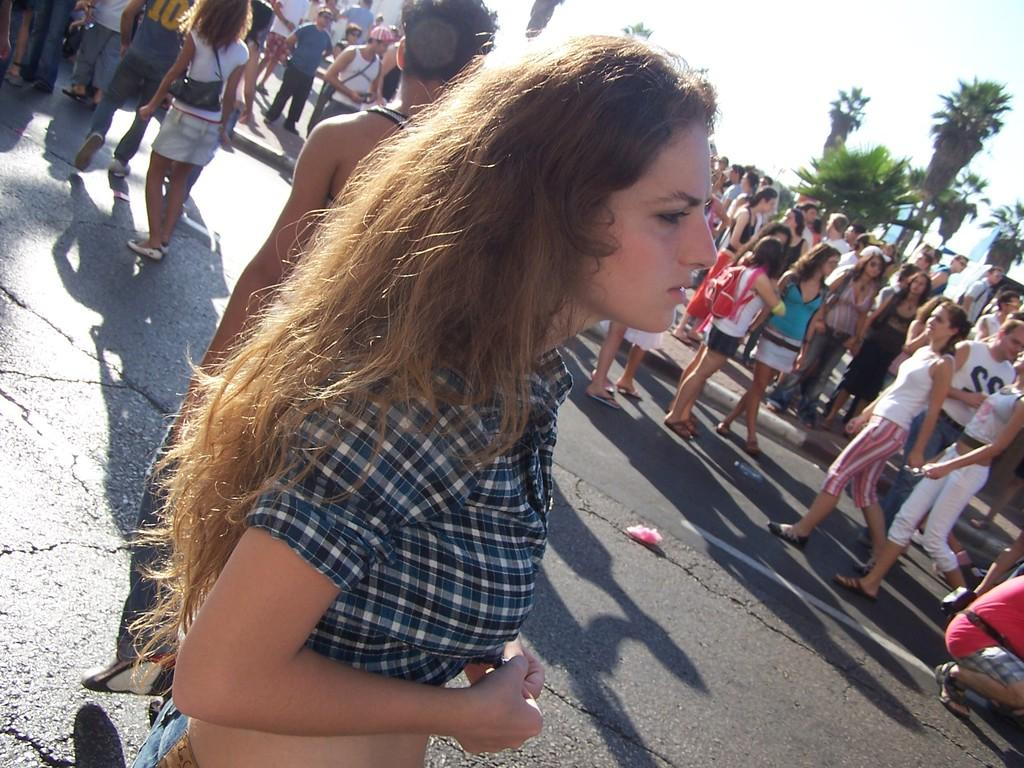What is happening on the road in the image? There is a group of people on the road in the image. What can be seen in the hands of the people or near them? There are bags visible in the image. What type of natural elements can be seen in the image? There are trees in the image. What else is present in the image besides the people and trees? There are some objects in the image. What is visible in the background of the image? The sky is visible in the background of the image. Can you tell me how many snails are crawling on the people in the image? There are no snails visible in the image; it only features a group of people, bags, trees, objects, and the sky. What type of apparatus is being used by the people in the image? There is no specific apparatus mentioned or visible in the image; the people are simply standing or walking with bags. 